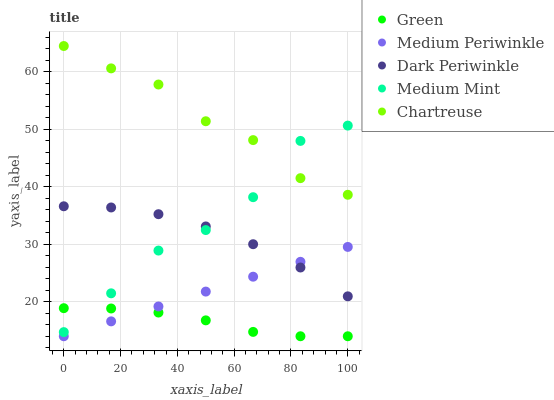Does Green have the minimum area under the curve?
Answer yes or no. Yes. Does Chartreuse have the maximum area under the curve?
Answer yes or no. Yes. Does Medium Periwinkle have the minimum area under the curve?
Answer yes or no. No. Does Medium Periwinkle have the maximum area under the curve?
Answer yes or no. No. Is Medium Periwinkle the smoothest?
Answer yes or no. Yes. Is Medium Mint the roughest?
Answer yes or no. Yes. Is Chartreuse the smoothest?
Answer yes or no. No. Is Chartreuse the roughest?
Answer yes or no. No. Does Medium Periwinkle have the lowest value?
Answer yes or no. Yes. Does Chartreuse have the lowest value?
Answer yes or no. No. Does Chartreuse have the highest value?
Answer yes or no. Yes. Does Medium Periwinkle have the highest value?
Answer yes or no. No. Is Dark Periwinkle less than Chartreuse?
Answer yes or no. Yes. Is Medium Mint greater than Medium Periwinkle?
Answer yes or no. Yes. Does Green intersect Medium Periwinkle?
Answer yes or no. Yes. Is Green less than Medium Periwinkle?
Answer yes or no. No. Is Green greater than Medium Periwinkle?
Answer yes or no. No. Does Dark Periwinkle intersect Chartreuse?
Answer yes or no. No. 